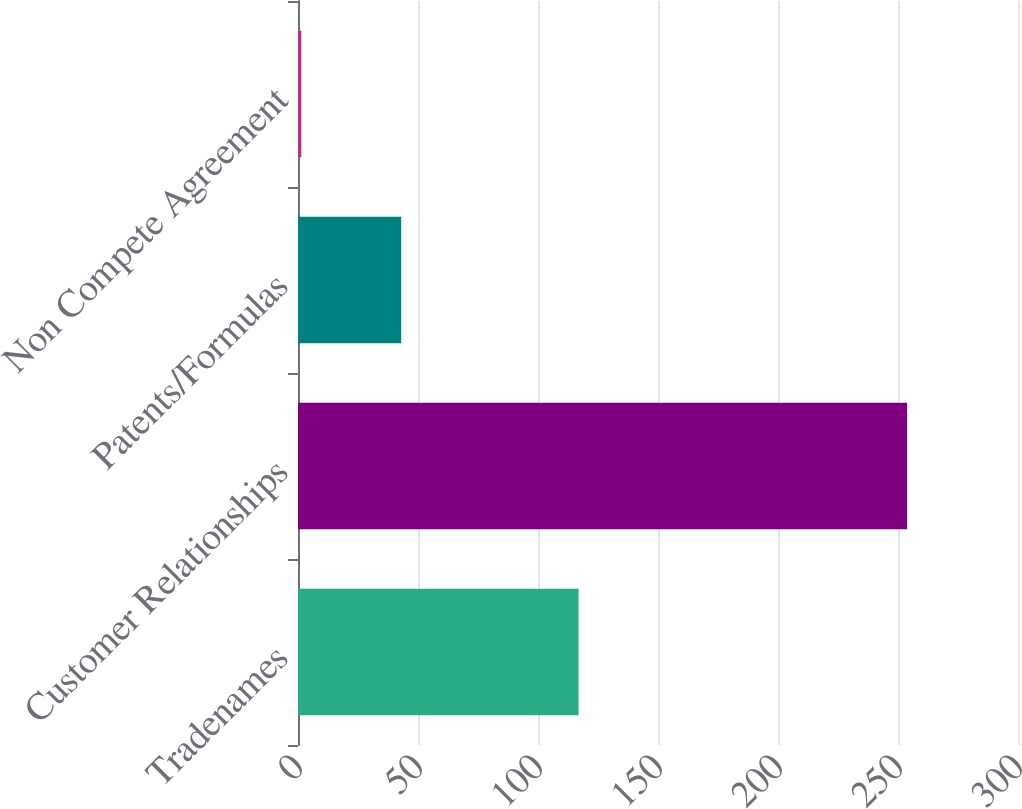Convert chart to OTSL. <chart><loc_0><loc_0><loc_500><loc_500><bar_chart><fcel>Tradenames<fcel>Customer Relationships<fcel>Patents/Formulas<fcel>Non Compete Agreement<nl><fcel>116.9<fcel>253.8<fcel>43<fcel>1.4<nl></chart> 